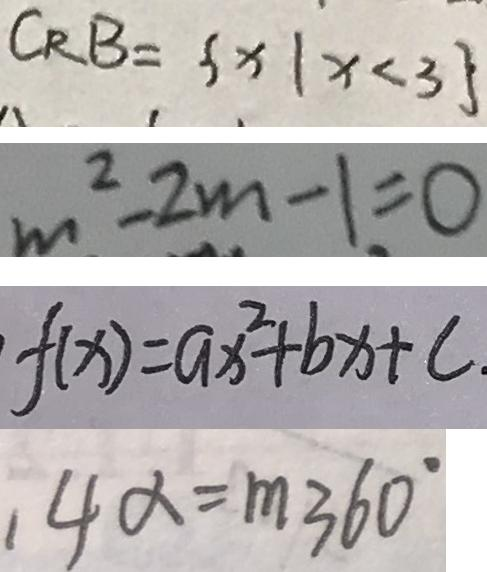Convert formula to latex. <formula><loc_0><loc_0><loc_500><loc_500>C _ { R } B = \{ x \vert x < 3 \} 
 m ^ { 2 } - 2 m - 1 = 0 
 f ( x ) = a x ^ { 2 } + b x + c 
 1 4 \alpha = m 3 6 0 ^ { \circ }</formula> 